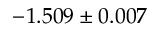Convert formula to latex. <formula><loc_0><loc_0><loc_500><loc_500>- 1 . 5 0 9 \pm 0 . 0 0 7</formula> 